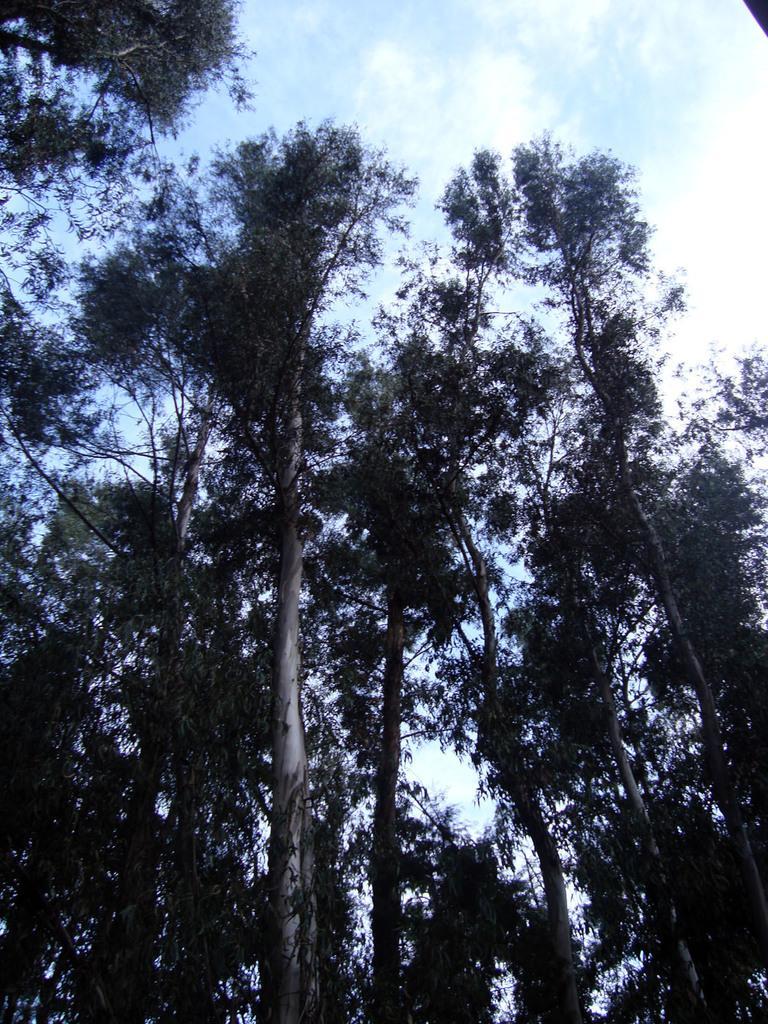Can you describe this image briefly? In this image we can see some trees and the sky with clouds. 